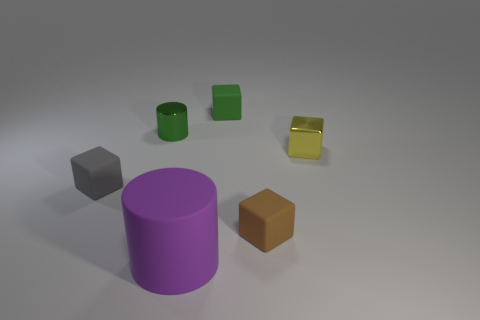There is a thing that is the same color as the tiny shiny cylinder; what material is it?
Offer a very short reply. Rubber. What number of things are big green rubber cylinders or green shiny objects?
Offer a very short reply. 1. There is a purple matte thing that is the same shape as the green shiny object; what is its size?
Provide a short and direct response. Large. Is there anything else that is the same size as the purple thing?
Ensure brevity in your answer.  No. How many other objects are the same color as the large object?
Keep it short and to the point. 0. What number of cylinders are either tiny green shiny things or tiny metallic things?
Offer a very short reply. 1. The small metal object that is to the left of the small matte cube that is on the right side of the small green matte cube is what color?
Ensure brevity in your answer.  Green. What is the shape of the large matte object?
Your answer should be very brief. Cylinder. Do the shiny object that is left of the yellow shiny cube and the large thing have the same size?
Make the answer very short. No. Is there a cylinder that has the same material as the tiny yellow object?
Give a very brief answer. Yes. 